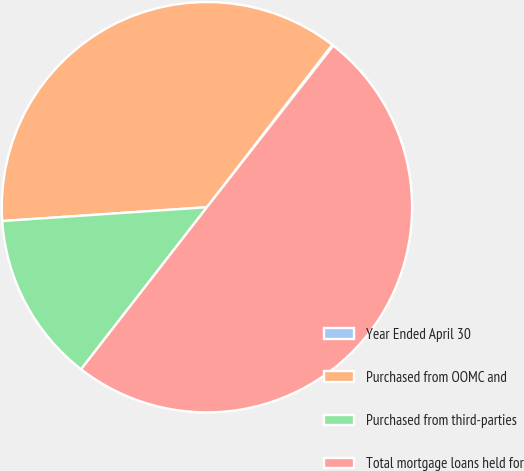<chart> <loc_0><loc_0><loc_500><loc_500><pie_chart><fcel>Year Ended April 30<fcel>Purchased from OOMC and<fcel>Purchased from third-parties<fcel>Total mortgage loans held for<nl><fcel>0.1%<fcel>36.53%<fcel>13.42%<fcel>49.95%<nl></chart> 